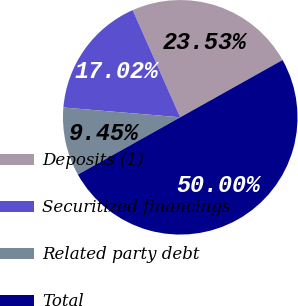<chart> <loc_0><loc_0><loc_500><loc_500><pie_chart><fcel>Deposits (1)<fcel>Securitized financings<fcel>Related party debt<fcel>Total<nl><fcel>23.53%<fcel>17.02%<fcel>9.45%<fcel>50.0%<nl></chart> 